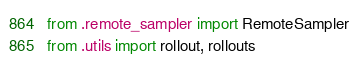<code> <loc_0><loc_0><loc_500><loc_500><_Python_>from .remote_sampler import RemoteSampler
from .utils import rollout, rollouts
</code> 